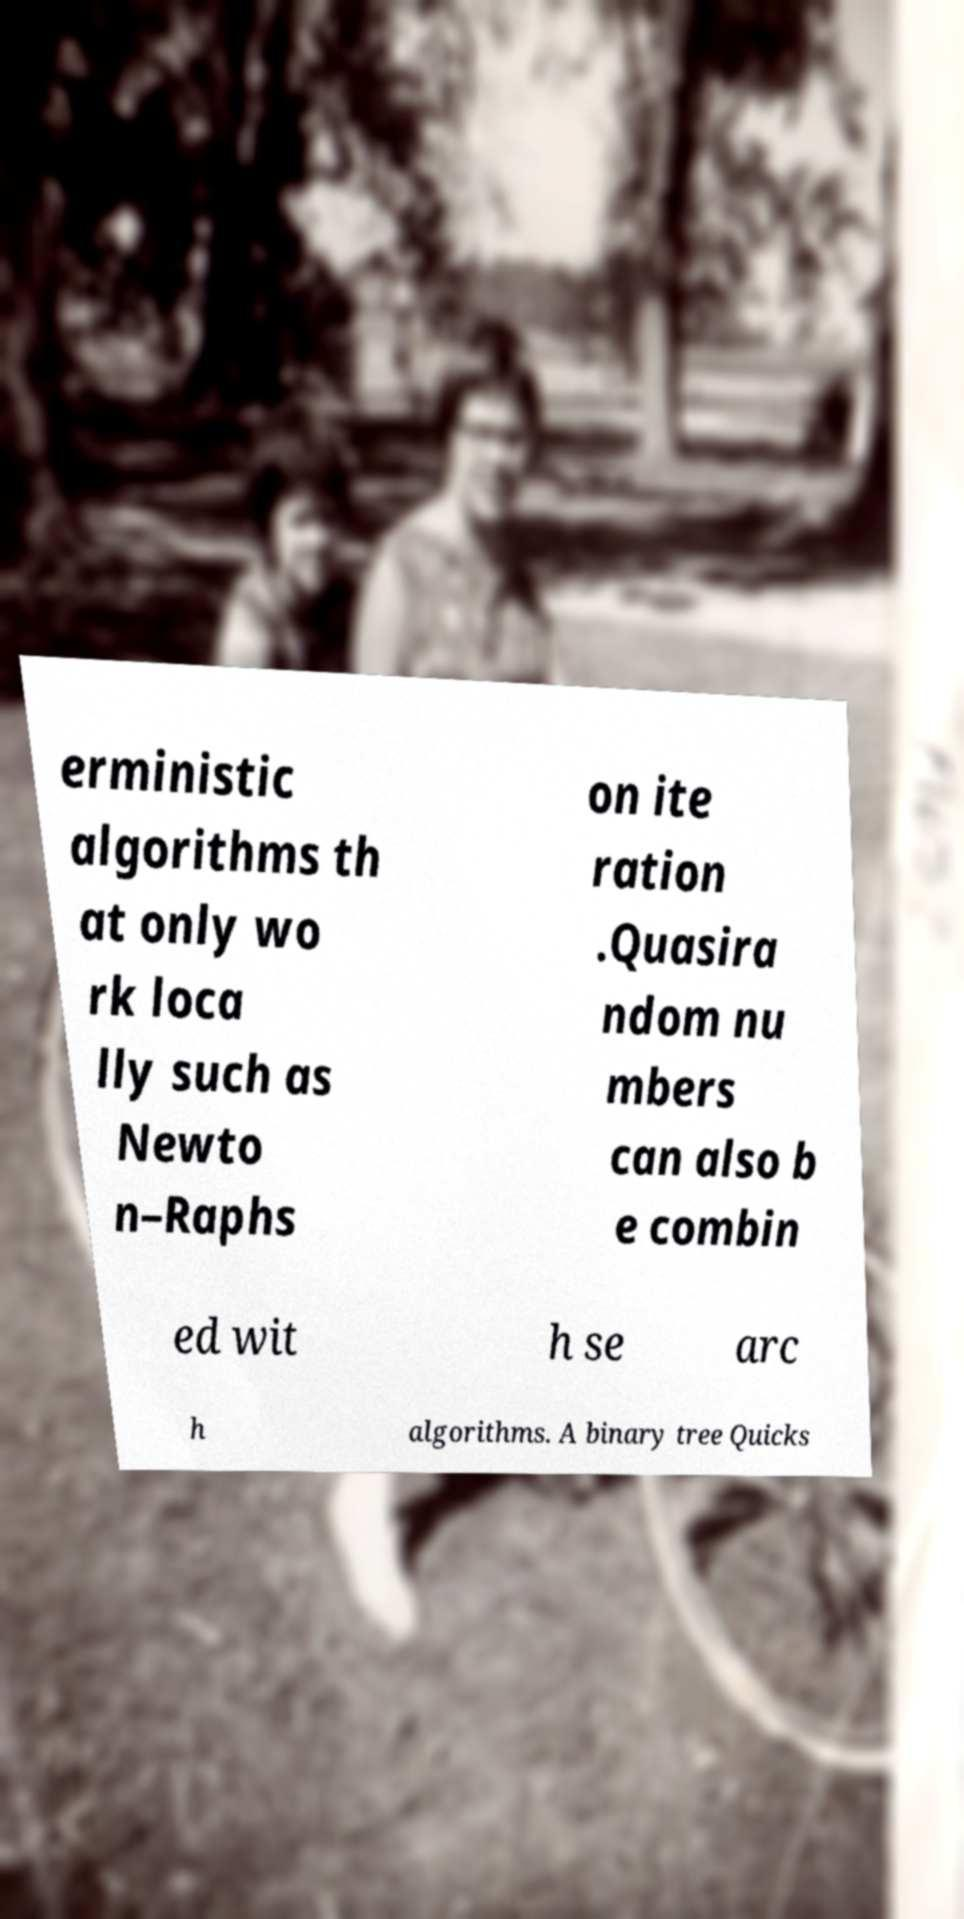Please identify and transcribe the text found in this image. erministic algorithms th at only wo rk loca lly such as Newto n–Raphs on ite ration .Quasira ndom nu mbers can also b e combin ed wit h se arc h algorithms. A binary tree Quicks 